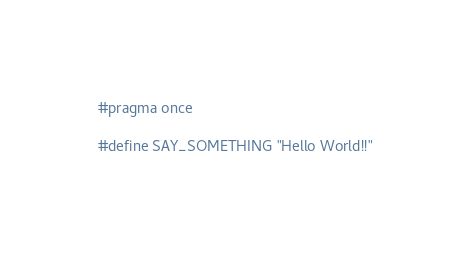<code> <loc_0><loc_0><loc_500><loc_500><_C_>#pragma once

#define SAY_SOMETHING "Hello World!!"</code> 